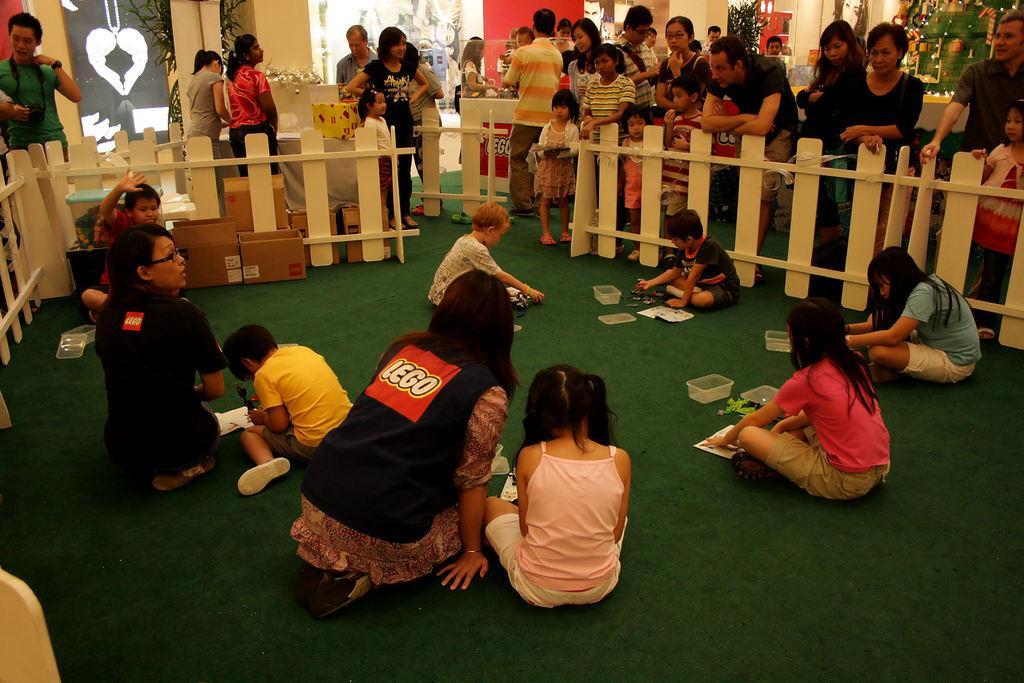How would you summarize this image in a sentence or two? This is the picture of a place where we have some people sitting on the floor and around there is a fencing and some people standing in front of the fencing and also we can see some plants and some other things around. 